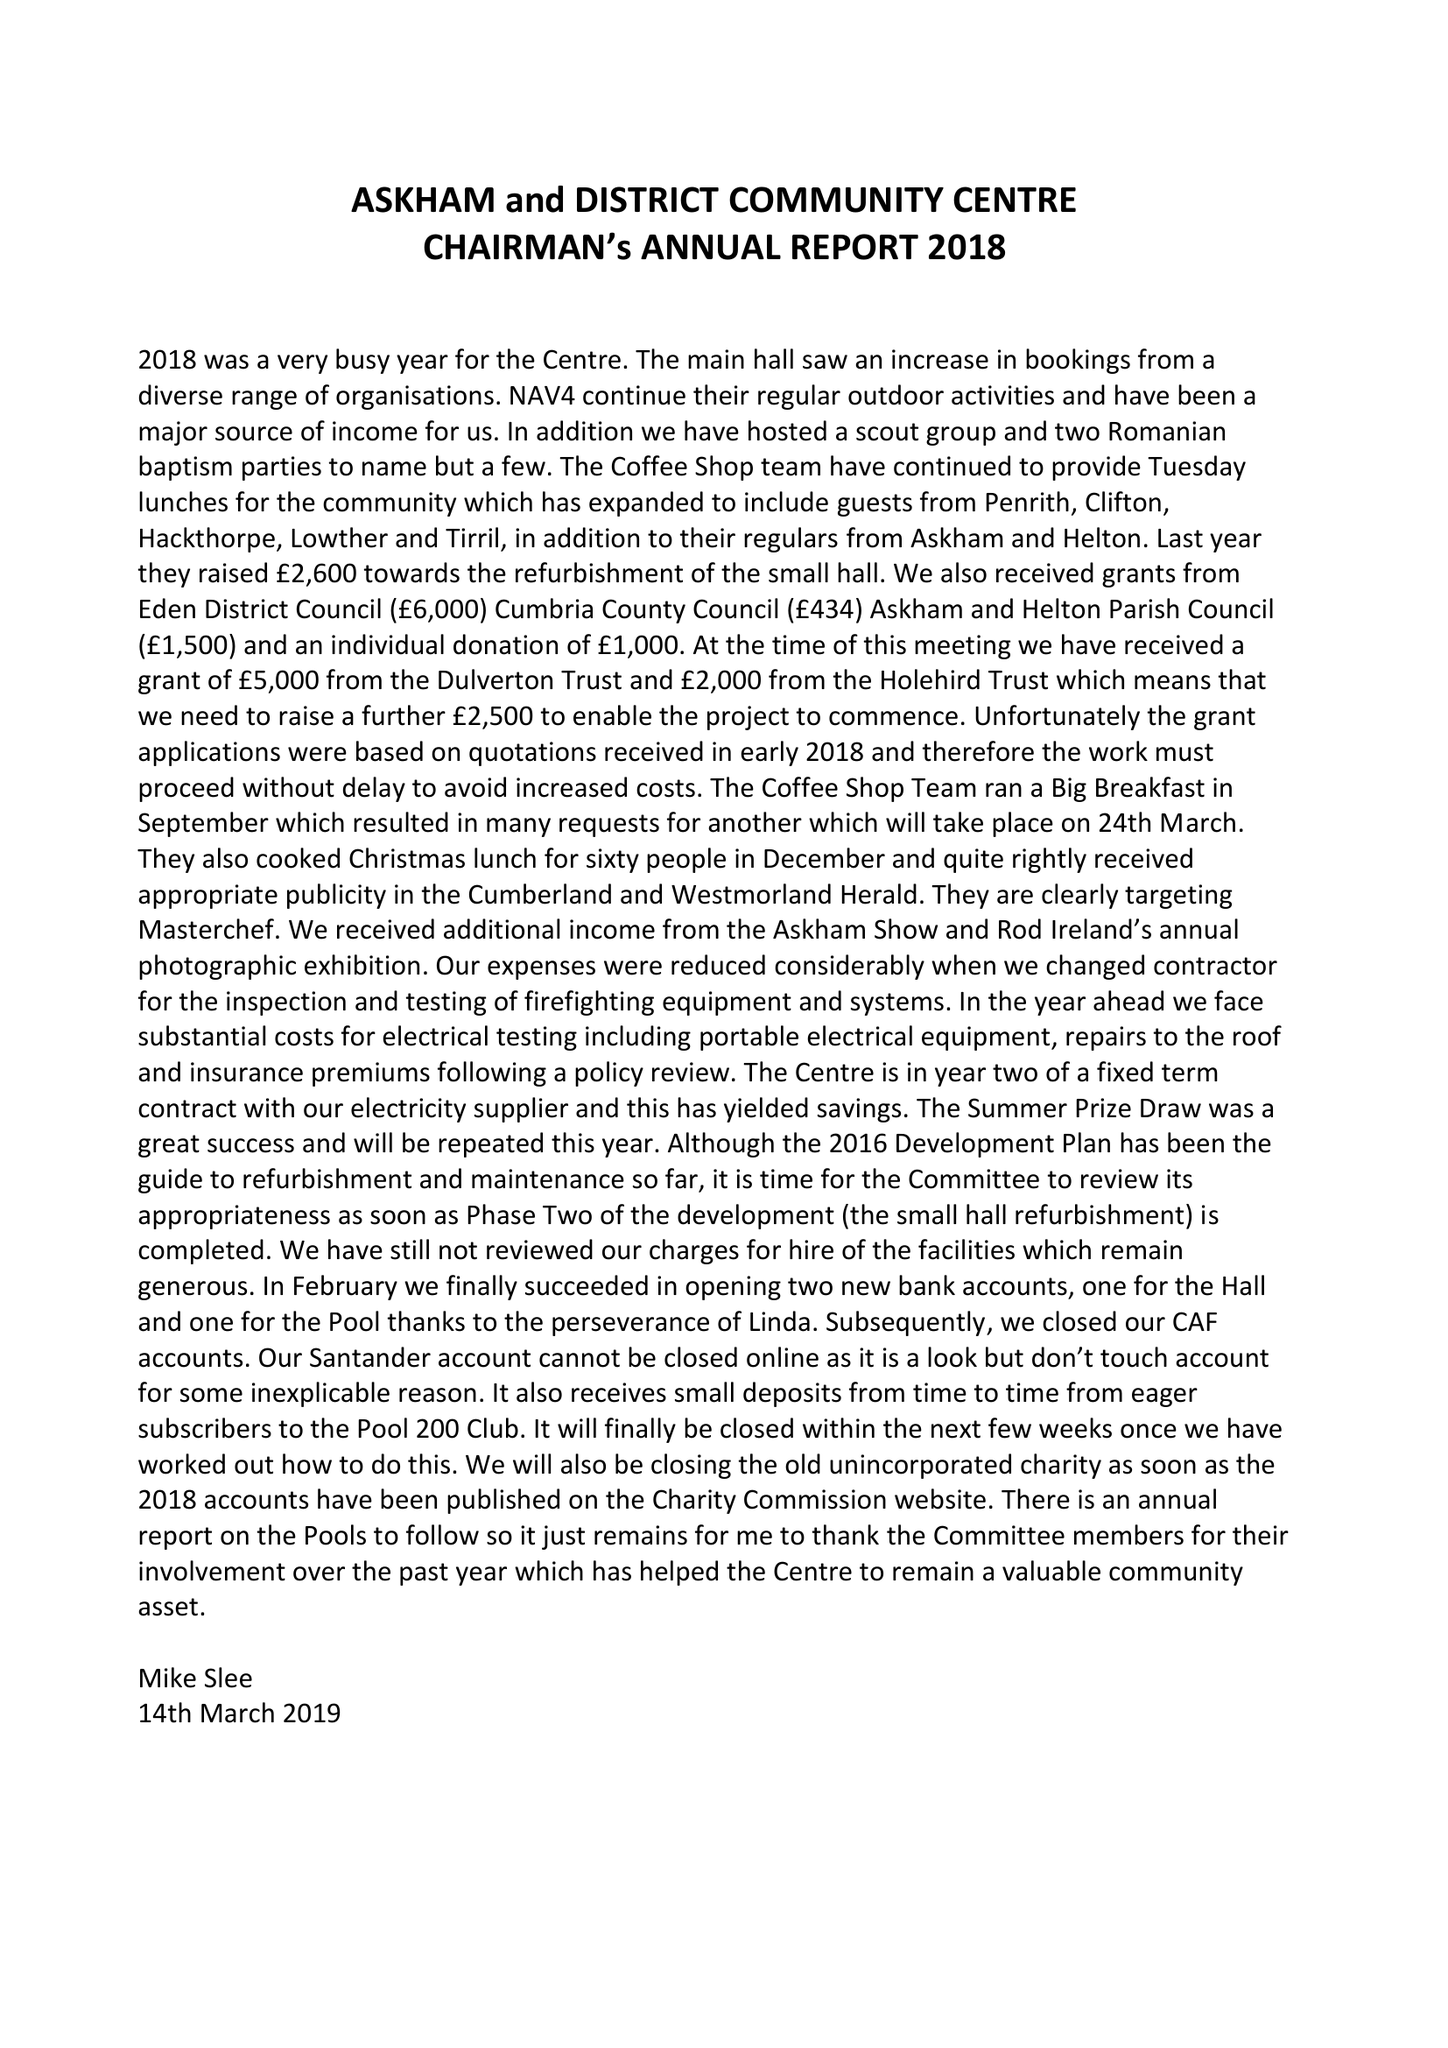What is the value for the charity_name?
Answer the question using a single word or phrase. Askham and District Community Centre 